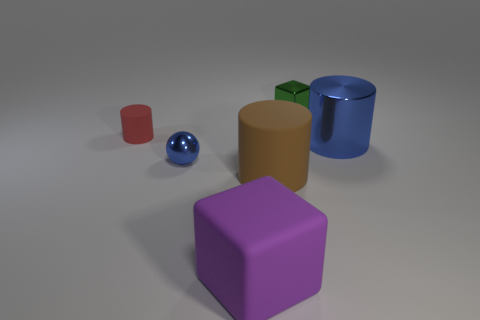Add 1 large purple things. How many objects exist? 7 Subtract all blocks. How many objects are left? 4 Subtract all small gray matte cubes. Subtract all brown cylinders. How many objects are left? 5 Add 2 large brown matte objects. How many large brown matte objects are left? 3 Add 6 tiny red matte things. How many tiny red matte things exist? 7 Subtract 1 red cylinders. How many objects are left? 5 